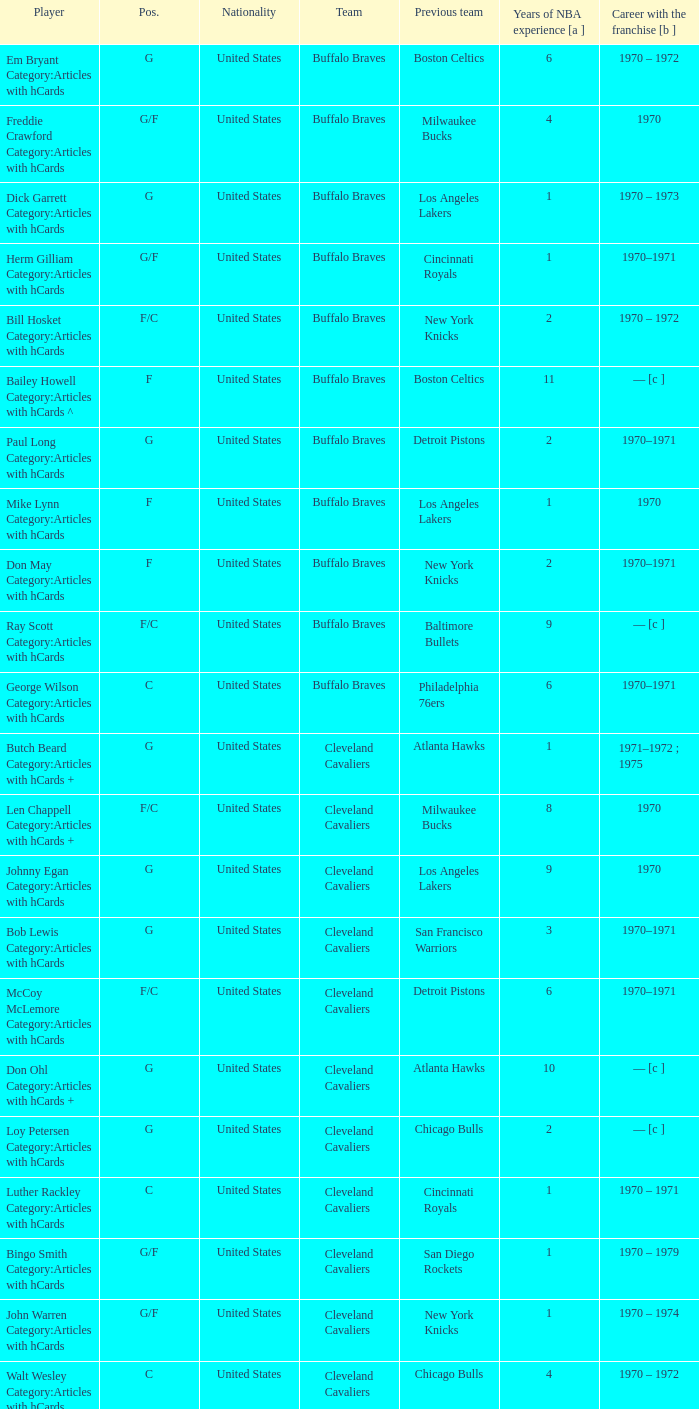Who is the player with 7 years of NBA experience? Larry Siegfried Category:Articles with hCards. 